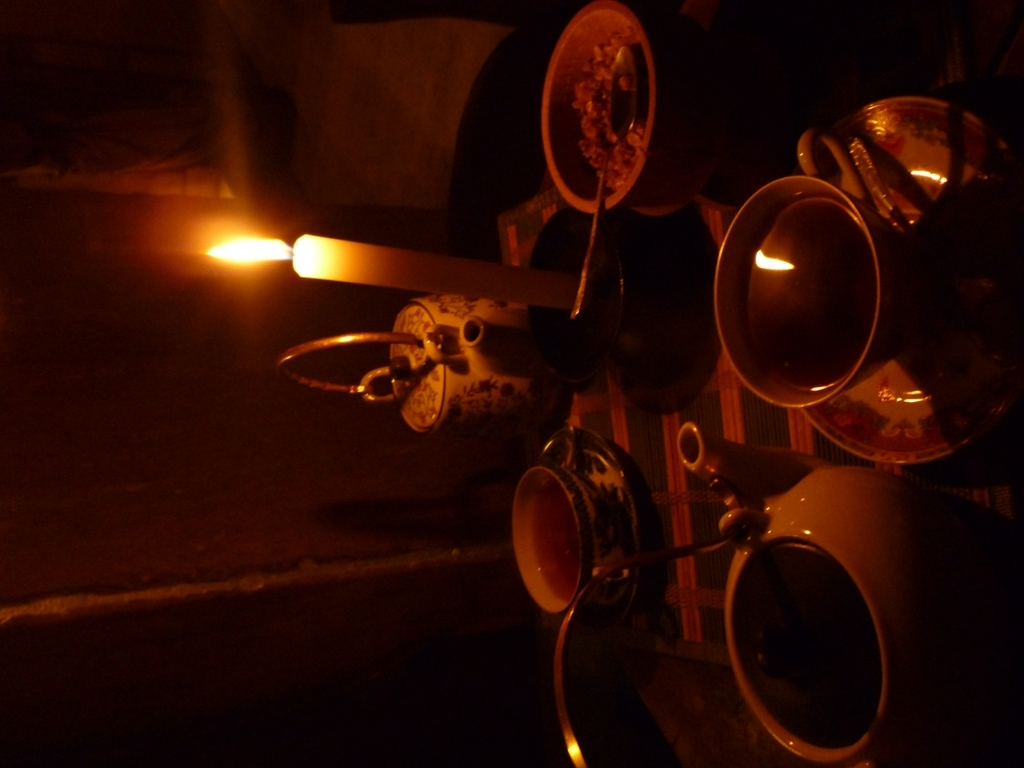What can we infer about the location where this photo was taken based on the items in the image? The items within the image, such as the ornate teacups and teapot, suggest a setting that might appreciate tradition and cultural rituals. Considering the intimate nature of the setting, it could be inside a home or a small, cozy cafe. The style of the teaware hints at an influence from cultures where tea drinking is an established custom, potentially East Asian. The dimmed lighting and candle use might indicate that this location is intended for relaxed, unhurried experiences. 